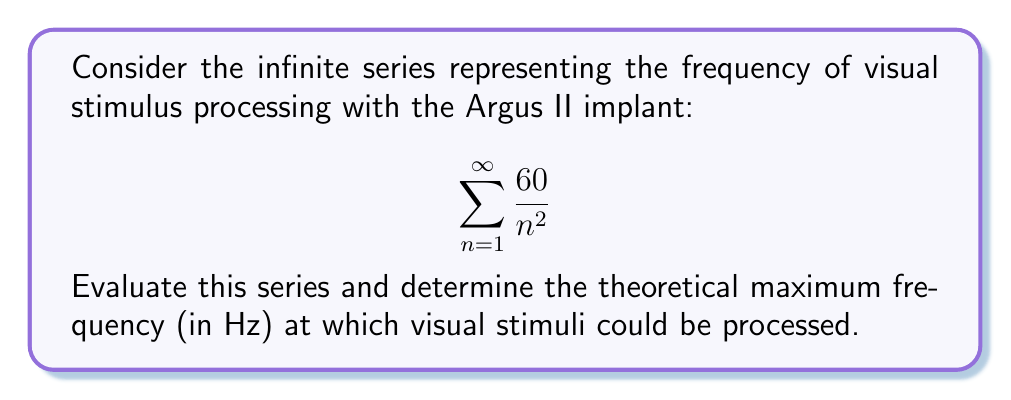Show me your answer to this math problem. Let's approach this step-by-step:

1) First, recognize that this series is in the form of:

   $$\sum_{n=1}^{\infty} \frac{k}{n^2}$$

   where $k = 60$.

2) This is a p-series with $p = 2$. We know that for $p > 1$, the p-series converges.

3) The sum of this particular p-series (when $k = 1$) is known to be:

   $$\sum_{n=1}^{\infty} \frac{1}{n^2} = \frac{\pi^2}{6}$$

   This is known as the Basel problem solution.

4) In our case, we have a factor of 60 outside. So our sum will be:

   $$60 \cdot \sum_{n=1}^{\infty} \frac{1}{n^2} = 60 \cdot \frac{\pi^2}{6}$$

5) Simplify:
   
   $$60 \cdot \frac{\pi^2}{6} = 10\pi^2 \approx 98.696 \text{ Hz}$$

6) Therefore, the theoretical maximum frequency at which visual stimuli could be processed is approximately 98.696 Hz.

This result suggests that with the Argus II implant, visual information could potentially be processed at a rate close to 100 times per second, which is quite rapid and could contribute to a smoother visual experience for the user.
Answer: $10\pi^2 \approx 98.696 \text{ Hz}$ 